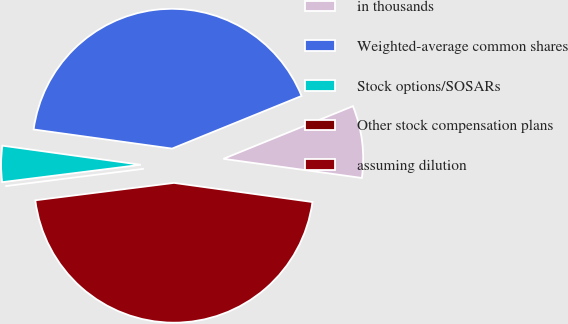Convert chart to OTSL. <chart><loc_0><loc_0><loc_500><loc_500><pie_chart><fcel>in thousands<fcel>Weighted-average common shares<fcel>Stock options/SOSARs<fcel>Other stock compensation plans<fcel>assuming dilution<nl><fcel>8.33%<fcel>41.67%<fcel>4.17%<fcel>0.0%<fcel>45.83%<nl></chart> 